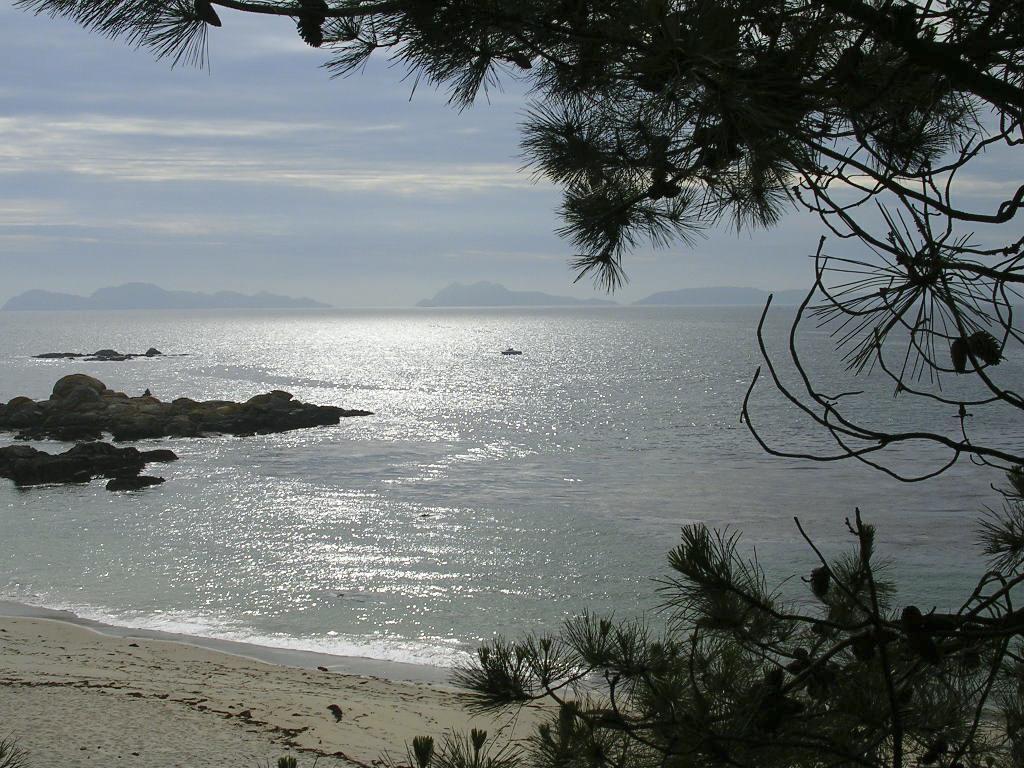Please provide a concise description of this image. In this image I can see in the middle it looks like the sea, on the right side there are trees, at the top it is the sky. 